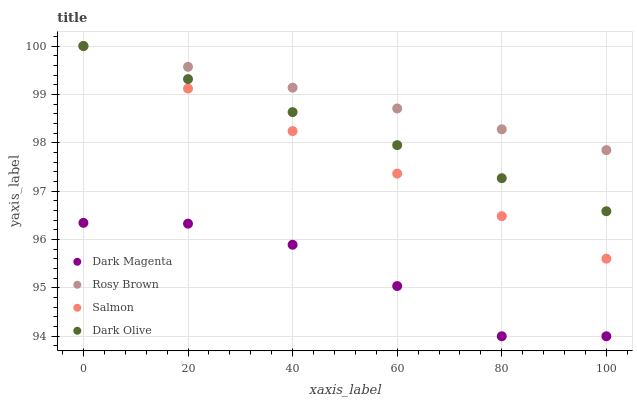Does Dark Magenta have the minimum area under the curve?
Answer yes or no. Yes. Does Rosy Brown have the maximum area under the curve?
Answer yes or no. Yes. Does Salmon have the minimum area under the curve?
Answer yes or no. No. Does Salmon have the maximum area under the curve?
Answer yes or no. No. Is Dark Olive the smoothest?
Answer yes or no. Yes. Is Dark Magenta the roughest?
Answer yes or no. Yes. Is Rosy Brown the smoothest?
Answer yes or no. No. Is Rosy Brown the roughest?
Answer yes or no. No. Does Dark Magenta have the lowest value?
Answer yes or no. Yes. Does Salmon have the lowest value?
Answer yes or no. No. Does Salmon have the highest value?
Answer yes or no. Yes. Does Dark Magenta have the highest value?
Answer yes or no. No. Is Dark Magenta less than Salmon?
Answer yes or no. Yes. Is Dark Olive greater than Dark Magenta?
Answer yes or no. Yes. Does Salmon intersect Dark Olive?
Answer yes or no. Yes. Is Salmon less than Dark Olive?
Answer yes or no. No. Is Salmon greater than Dark Olive?
Answer yes or no. No. Does Dark Magenta intersect Salmon?
Answer yes or no. No. 